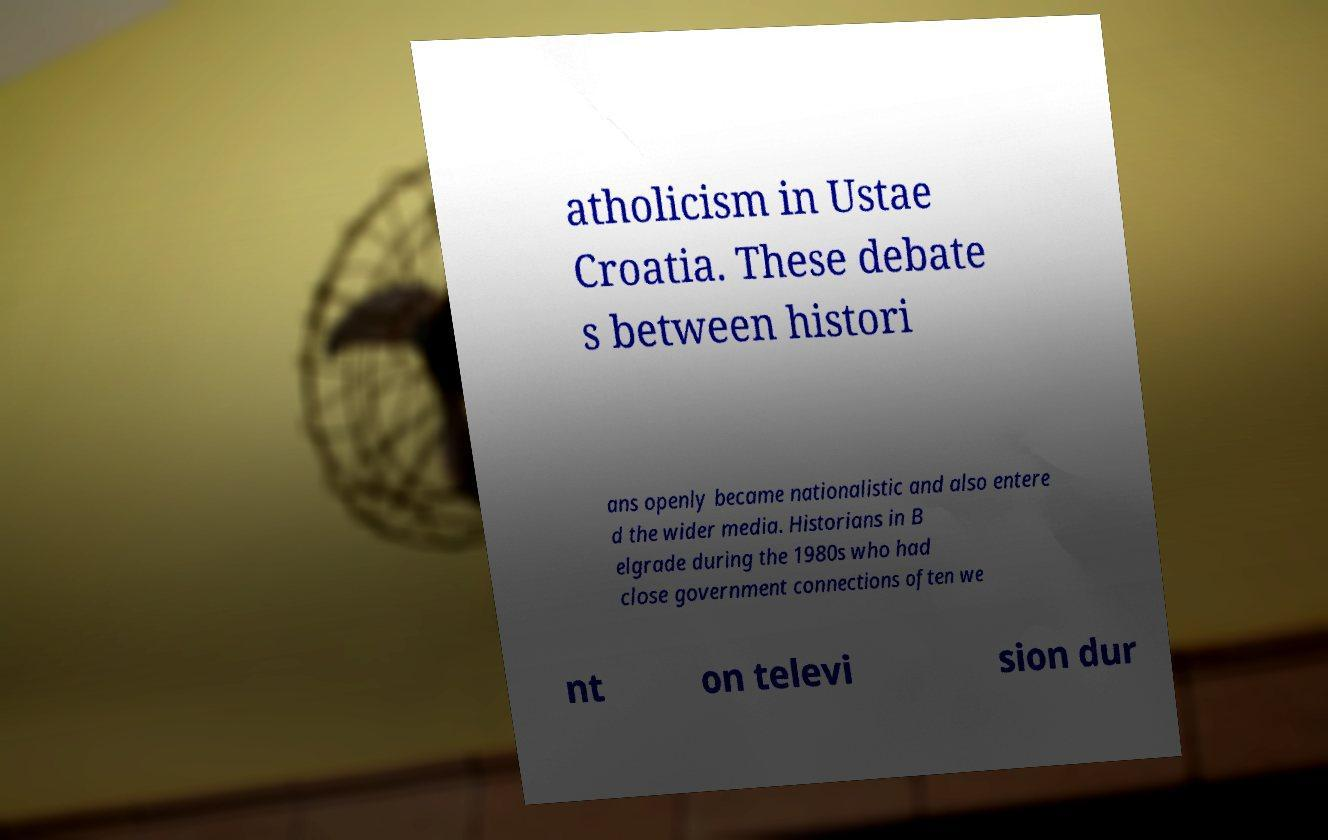Please identify and transcribe the text found in this image. atholicism in Ustae Croatia. These debate s between histori ans openly became nationalistic and also entere d the wider media. Historians in B elgrade during the 1980s who had close government connections often we nt on televi sion dur 